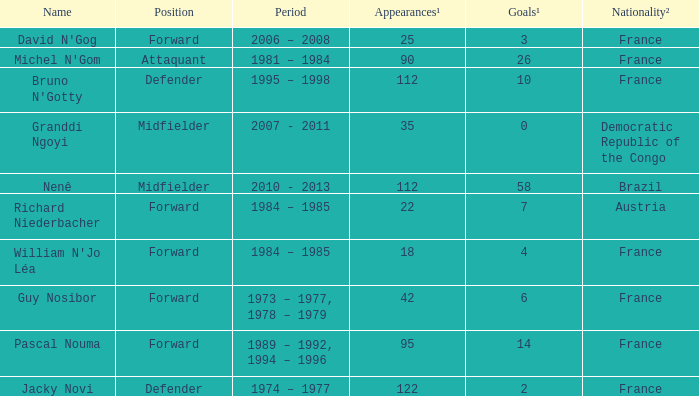How many games had less than 7 goals scored? 1.0. 